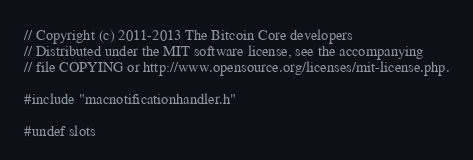Convert code to text. <code><loc_0><loc_0><loc_500><loc_500><_ObjectiveC_>// Copyright (c) 2011-2013 The Bitcoin Core developers
// Distributed under the MIT software license, see the accompanying
// file COPYING or http://www.opensource.org/licenses/mit-license.php.

#include "macnotificationhandler.h"

#undef slots</code> 